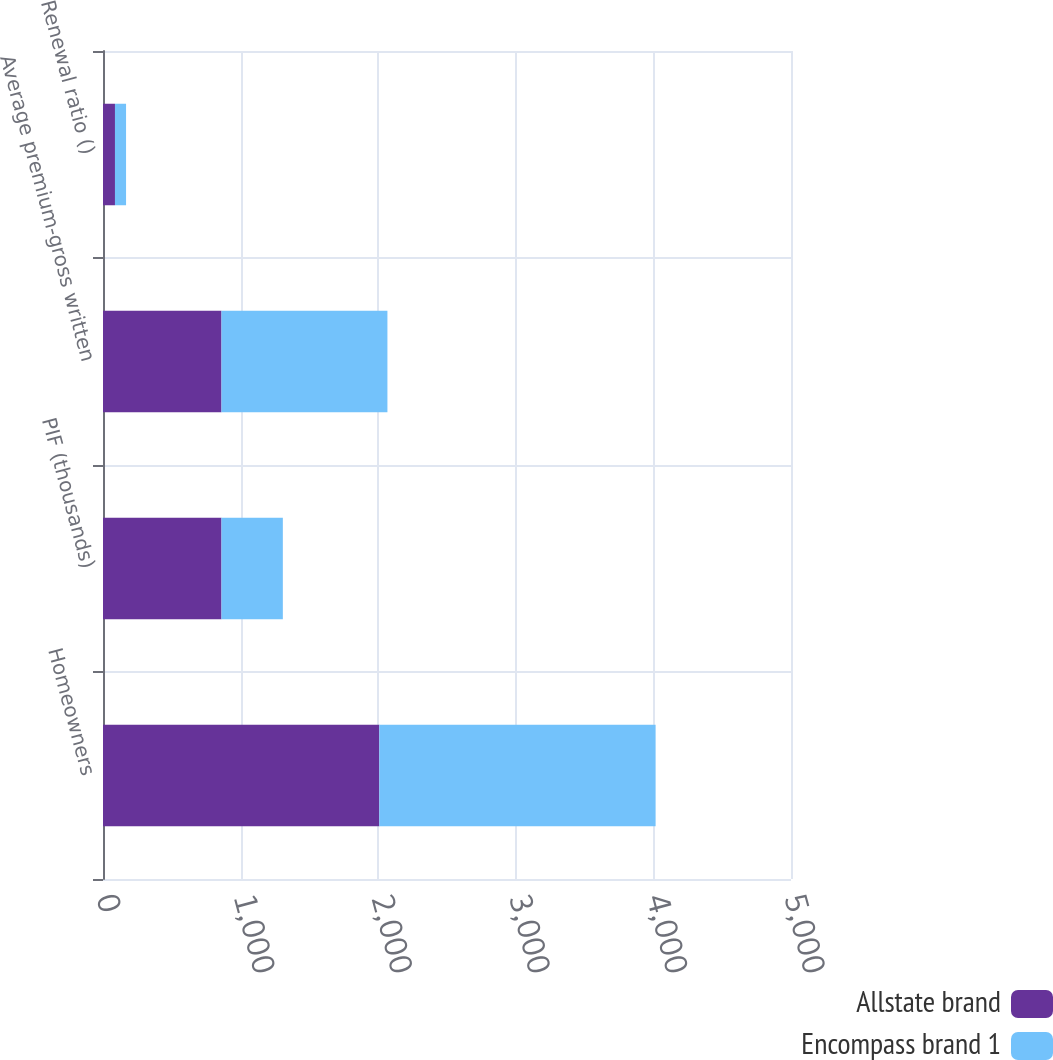Convert chart to OTSL. <chart><loc_0><loc_0><loc_500><loc_500><stacked_bar_chart><ecel><fcel>Homeowners<fcel>PIF (thousands)<fcel>Average premium-gross written<fcel>Renewal ratio ()<nl><fcel>Allstate brand<fcel>2008<fcel>861<fcel>861<fcel>87<nl><fcel>Encompass brand 1<fcel>2008<fcel>446<fcel>1206<fcel>80.6<nl></chart> 